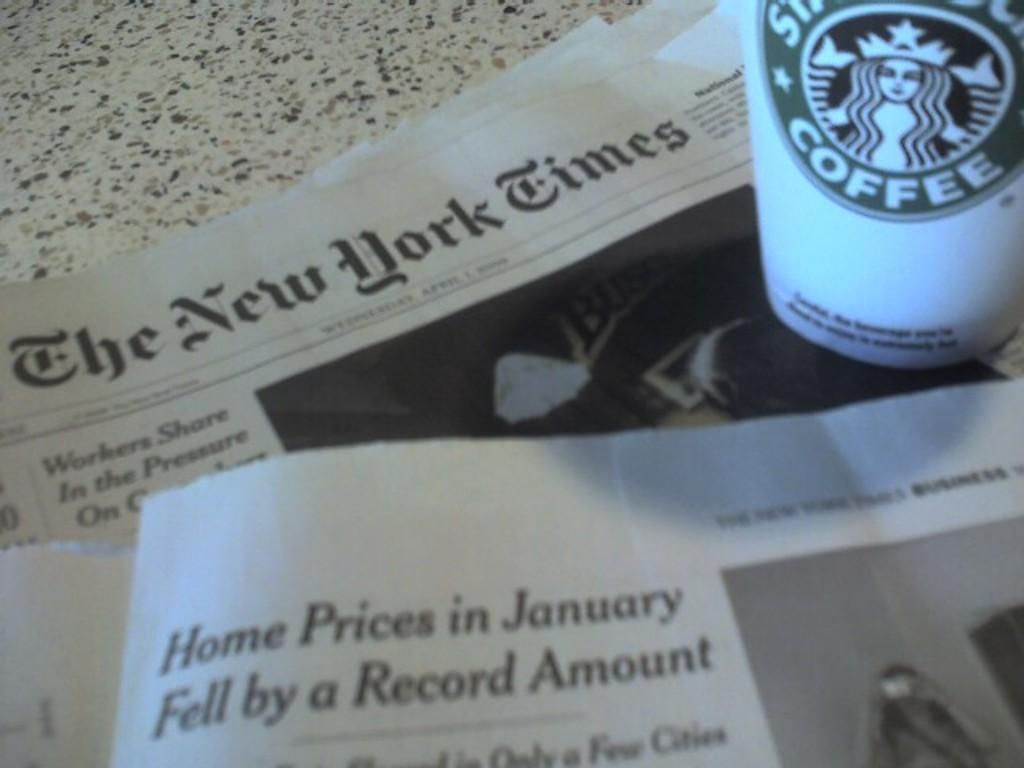What piece of furniture is present in the image? There is a table in the image. What items are placed on the table? There are newspapers and a coffee tumbler on the table. What type of plants can be seen growing inside the coffee tumbler in the image? There are no plants visible inside the coffee tumbler in the image. 